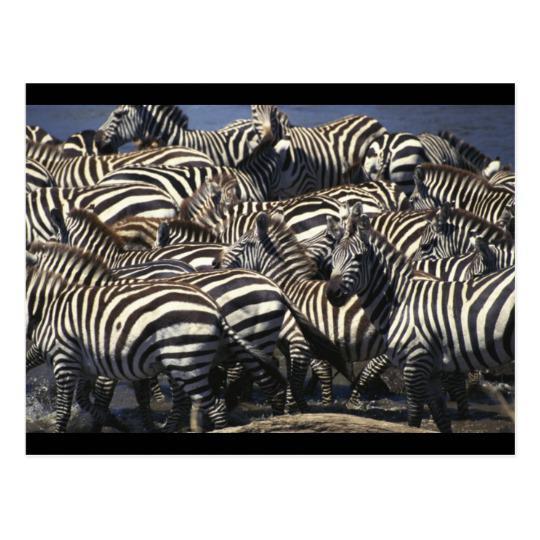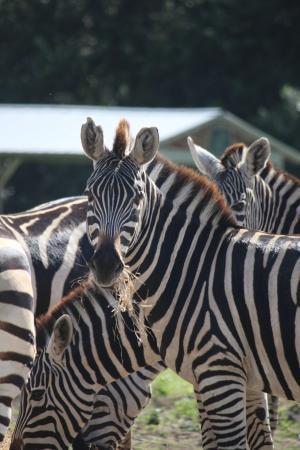The first image is the image on the left, the second image is the image on the right. Evaluate the accuracy of this statement regarding the images: "There are at most 6 zebras in the image pair". Is it true? Answer yes or no. No. The first image is the image on the left, the second image is the image on the right. Given the left and right images, does the statement "There are exactly two zebras in the left image." hold true? Answer yes or no. No. 